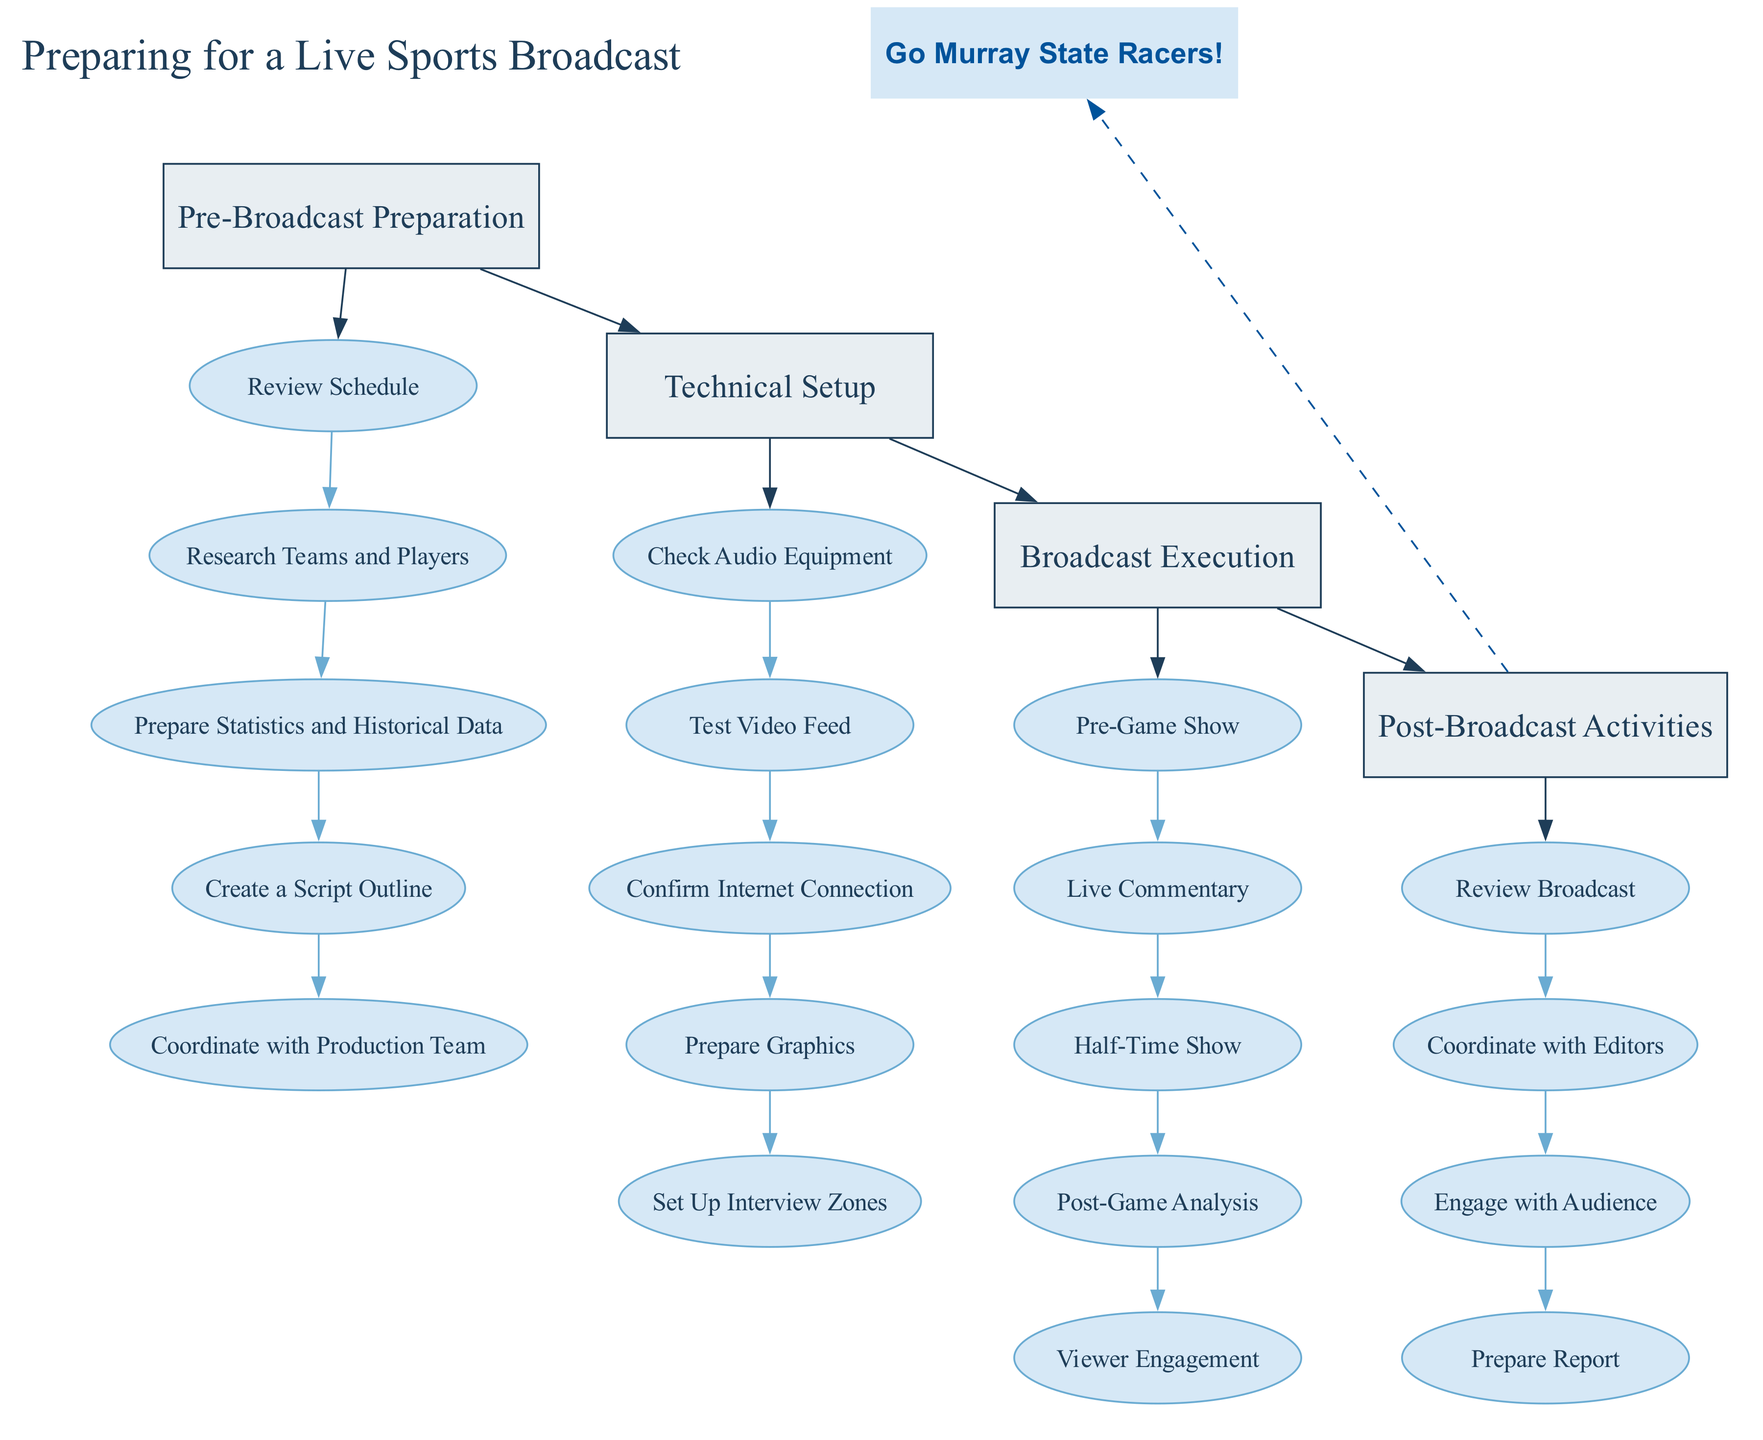What are the four main stages of preparing for a live sports broadcast? The four main stages are Pre-Broadcast Preparation, Technical Setup, Broadcast Execution, and Post-Broadcast Activities. These categories are visually represented as boxes in the diagram, indicating the sequential steps of the workflow.
Answer: Pre-Broadcast Preparation, Technical Setup, Broadcast Execution, Post-Broadcast Activities How many tasks are listed under Technical Setup? Under the Technical Setup stage, there are five tasks outlined: Check Audio Equipment, Test Video Feed, Confirm Internet Connection, Prepare Graphics, and Set Up Interview Zones. Counting each task provides the total.
Answer: 5 What task comes after "Research Teams and Players"? The task that follows "Research Teams and Players" in the Pre-Broadcast Preparation stage is "Prepare Statistics and Historical Data." This can be identified by tracing the connections in that segment of the diagram.
Answer: Prepare Statistics and Historical Data Which stage has a dashed connection to "Go Murray State Racers!"? The stage that has a dashed connection to "Go Murray State Racers!" is Post-Broadcast Activities. This type of edge indicates a special relationship, and it can be observed directly from the diagram layout.
Answer: Post-Broadcast Activities What is the purpose of the "Pre-Game Show"? The purpose of the "Pre-Game Show" is to engage viewers with key insights and player spotlights. This is directly related to what is described in the Broadcast Execution stage of the diagram.
Answer: Engage viewers with key insights and player spotlights How many tasks are there in total under all stages? By counting each task listed under each of the four main stages (5 in Pre-Broadcast Preparation, 5 in Technical Setup, 5 in Broadcast Execution, and 4 in Post-Broadcast Activities), we get a total of 19 tasks. Adding all counts together gives the final figure.
Answer: 19 Which task involves engaging with the audience on social media? The task that involves engaging with the audience on social media is "Viewer Engagement," found under the Broadcast Execution stage. It emphasizes interaction with viewers during the live broadcast.
Answer: Viewer Engagement What is the first task listed under Post-Broadcast Activities? The first task listed under Post-Broadcast Activities is "Review Broadcast." This is seen as the initial activity after the live broadcast and is clearly positioned at the top of that stage’s list.
Answer: Review Broadcast 